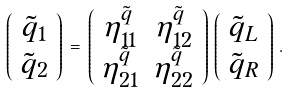Convert formula to latex. <formula><loc_0><loc_0><loc_500><loc_500>\left ( \begin{array} { c } \tilde { q } _ { 1 } \\ \tilde { q } _ { 2 } \end{array} \right ) \, = \, \left ( \begin{array} { c c } \eta _ { 1 1 } ^ { \tilde { q } } & \eta _ { 1 2 } ^ { \tilde { q } } \\ \eta _ { 2 1 } ^ { \tilde { q } } & \eta _ { 2 2 } ^ { \tilde { q } } \end{array} \right ) \, \left ( \begin{array} { c } \tilde { q } _ { L } \\ \tilde { q } _ { R } \end{array} \right ) \, .</formula> 